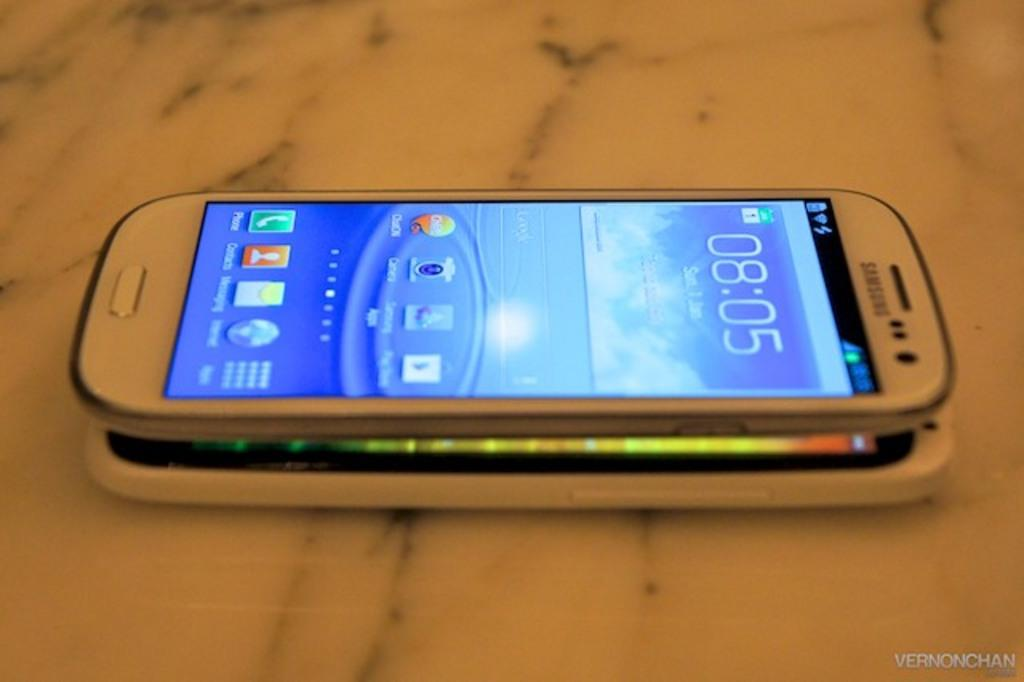<image>
Write a terse but informative summary of the picture. a phone face up on a table with 08.05 displaying on the screen 